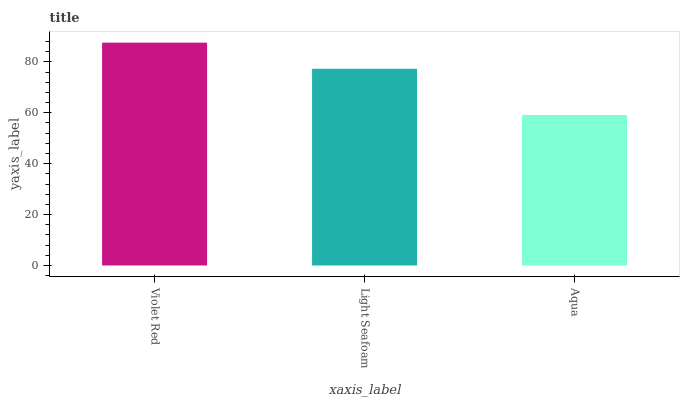Is Aqua the minimum?
Answer yes or no. Yes. Is Violet Red the maximum?
Answer yes or no. Yes. Is Light Seafoam the minimum?
Answer yes or no. No. Is Light Seafoam the maximum?
Answer yes or no. No. Is Violet Red greater than Light Seafoam?
Answer yes or no. Yes. Is Light Seafoam less than Violet Red?
Answer yes or no. Yes. Is Light Seafoam greater than Violet Red?
Answer yes or no. No. Is Violet Red less than Light Seafoam?
Answer yes or no. No. Is Light Seafoam the high median?
Answer yes or no. Yes. Is Light Seafoam the low median?
Answer yes or no. Yes. Is Aqua the high median?
Answer yes or no. No. Is Aqua the low median?
Answer yes or no. No. 